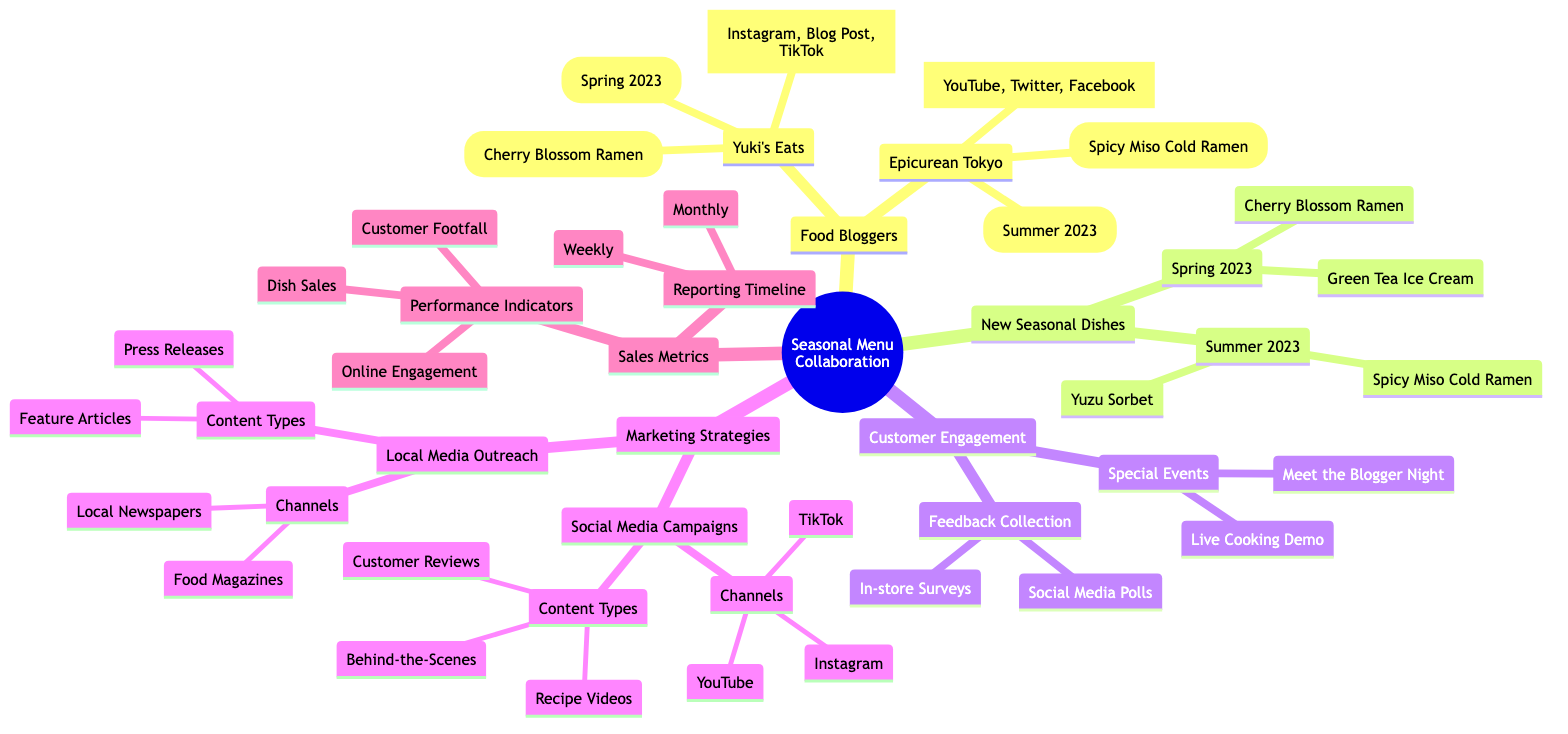What special dish was created with Yuki's Eats? The diagram shows that the special dish created with Yuki's Eats is the Cherry Blossom Ramen. This is found under the Food Bloggers section, specifically relating to Yuki's Eats.
Answer: Cherry Blossom Ramen When did the collaboration with Epicurean Tokyo occur? According to the diagram, the collaboration with Epicurean Tokyo took place in Summer 2023, which is indicated under the Food Bloggers section for Epicurean Tokyo.
Answer: Summer 2023 What are the customer engagement methods listed? The diagram lists two categories for customer engagement: Feedback Collection and Special Events. Under Feedback Collection, it includes Social Media Polls and In-store Surveys. For Special Events, it lists Live Cooking Demo and Meet the Blogger Night.
Answer: Feedback Collection, Special Events How many special dishes are featured for Summer 2023? In the diagram, under New Seasonal Dishes for Summer 2023, there are two special dishes listed: Spicy Miso Cold Ramen and Yuzu Sorbet. Therefore, the count of special dishes is two.
Answer: 2 Which promotional channels were used for the Cherry Blossom Ramen? The diagram specifies that the promotional channels for the Cherry Blossom Ramen included Instagram, Blog Post, and TikTok. This information is directly linked to Yuki's Eats under the Food Bloggers section.
Answer: Instagram, Blog Post, TikTok Which marketing strategy involves recipe videos? The diagram shows that Social Media Campaigns include Recipe Videos as one of the content types. This is found in the Marketing Strategies section of the diagram.
Answer: Social Media Campaigns What are the performance indicators for sales metrics? The diagram lists the performance indicators for sales metrics as Dish Sales, Customer Footfall, and Online Engagement. This information is in the Sales Metrics section.
Answer: Dish Sales, Customer Footfall, Online Engagement How are social media channels structured in the marketing strategies? The diagram outlines that Social Media Campaigns have three channels: Instagram, YouTube, and TikTok. This is found within the Marketing Strategies section, specifically under Social Media Campaigns.
Answer: Instagram, YouTube, TikTok What seasonal dishes are available in Spring 2023? According to the diagram, the seasonal dishes available in Spring 2023 are Cherry Blossom Ramen and Green Tea Ice Cream. This information is under the New Seasonal Dishes section specifically for Spring 2023.
Answer: Cherry Blossom Ramen, Green Tea Ice Cream 